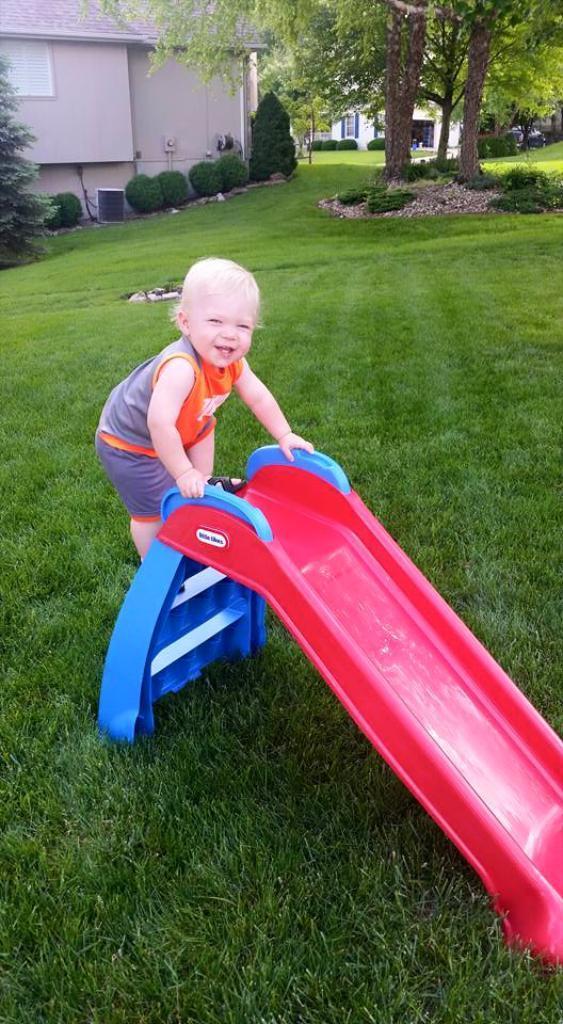Can you describe this image briefly? In the foreground of this image, there is a kid climbing on the slide which is on the grass. In the background, there are buildings, trees, shrubs and the grass. 